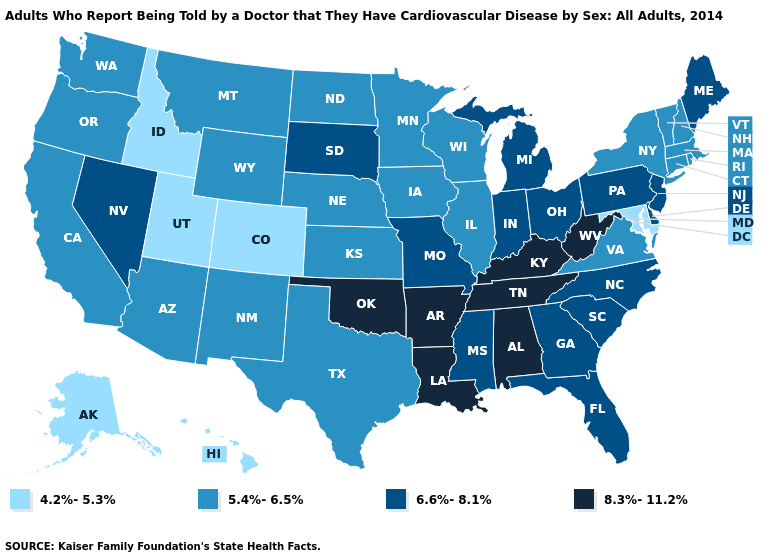Does Arkansas have the same value as Montana?
Be succinct. No. Name the states that have a value in the range 5.4%-6.5%?
Concise answer only. Arizona, California, Connecticut, Illinois, Iowa, Kansas, Massachusetts, Minnesota, Montana, Nebraska, New Hampshire, New Mexico, New York, North Dakota, Oregon, Rhode Island, Texas, Vermont, Virginia, Washington, Wisconsin, Wyoming. Does Wisconsin have the lowest value in the USA?
Write a very short answer. No. What is the value of Alaska?
Answer briefly. 4.2%-5.3%. Name the states that have a value in the range 5.4%-6.5%?
Keep it brief. Arizona, California, Connecticut, Illinois, Iowa, Kansas, Massachusetts, Minnesota, Montana, Nebraska, New Hampshire, New Mexico, New York, North Dakota, Oregon, Rhode Island, Texas, Vermont, Virginia, Washington, Wisconsin, Wyoming. Which states have the lowest value in the West?
Be succinct. Alaska, Colorado, Hawaii, Idaho, Utah. What is the value of Hawaii?
Write a very short answer. 4.2%-5.3%. Does Colorado have the lowest value in the West?
Answer briefly. Yes. What is the value of Kansas?
Give a very brief answer. 5.4%-6.5%. What is the value of Maryland?
Keep it brief. 4.2%-5.3%. Does Michigan have a higher value than North Dakota?
Keep it brief. Yes. What is the highest value in states that border South Dakota?
Short answer required. 5.4%-6.5%. What is the value of Louisiana?
Write a very short answer. 8.3%-11.2%. Does New Jersey have a higher value than Wisconsin?
Give a very brief answer. Yes. What is the value of Texas?
Quick response, please. 5.4%-6.5%. 